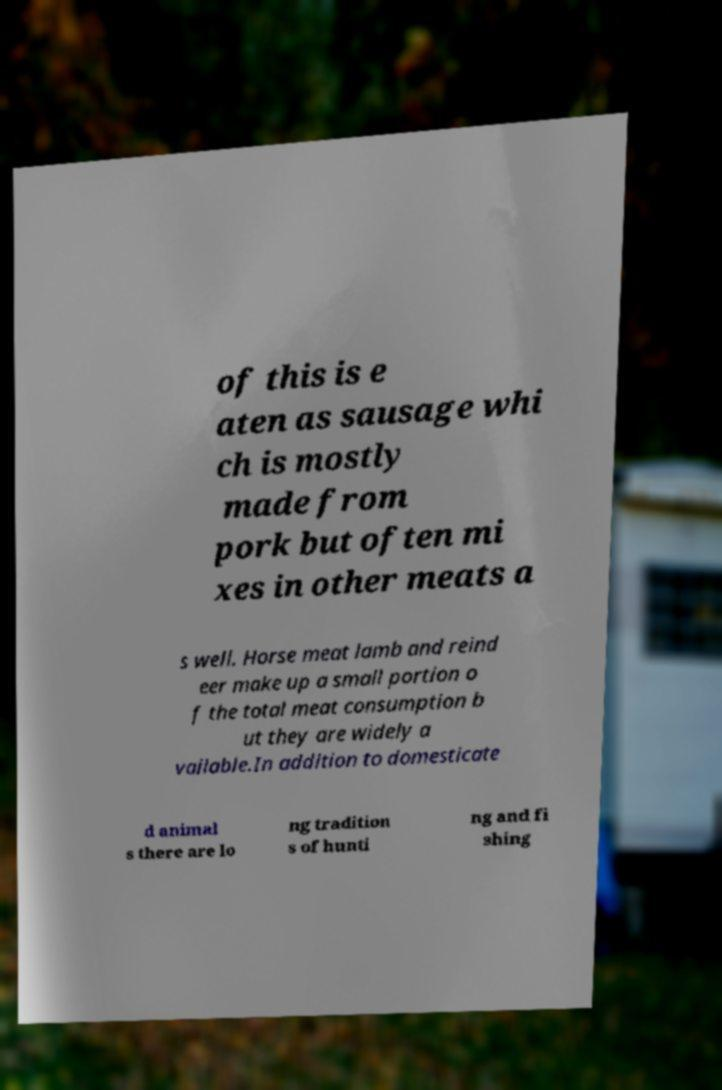Can you read and provide the text displayed in the image?This photo seems to have some interesting text. Can you extract and type it out for me? of this is e aten as sausage whi ch is mostly made from pork but often mi xes in other meats a s well. Horse meat lamb and reind eer make up a small portion o f the total meat consumption b ut they are widely a vailable.In addition to domesticate d animal s there are lo ng tradition s of hunti ng and fi shing 